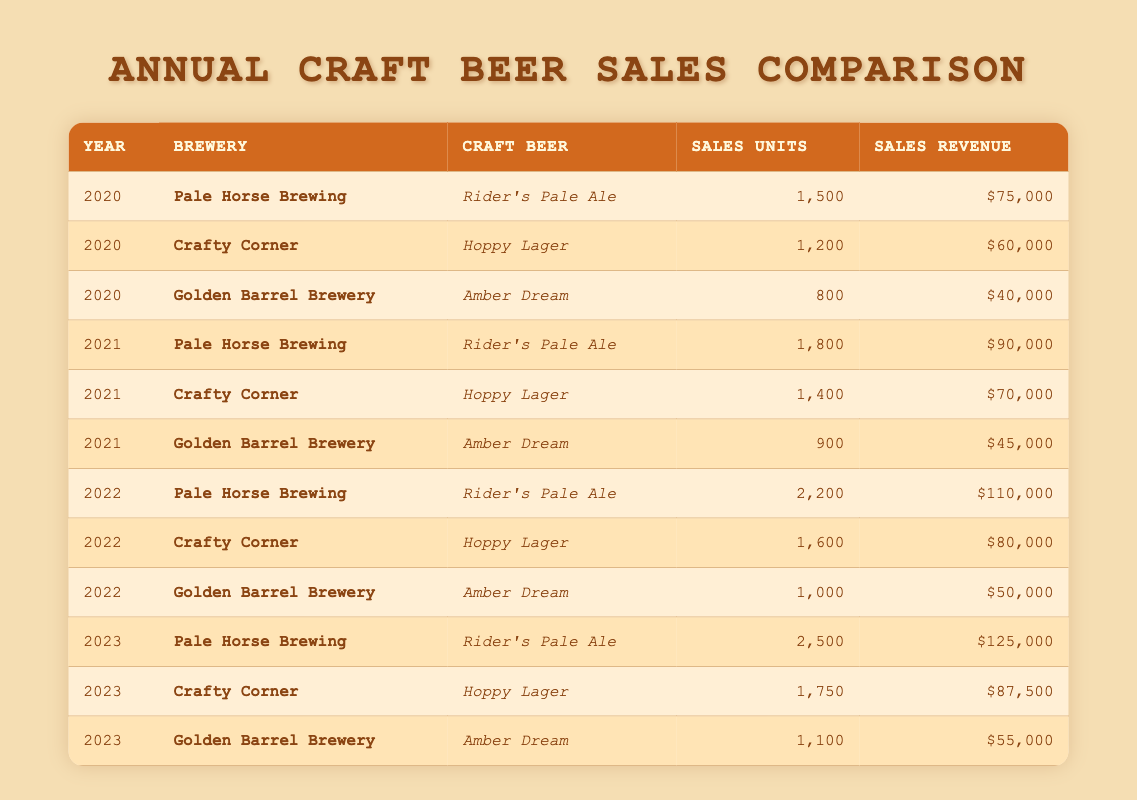What were the sales units for Rider's Pale Ale in 2021? In the table for the year 2021 and the brewery Pale Horse Brewing, the sales units for Rider's Pale Ale are listed as 1800.
Answer: 1800 What is the sales revenue for Hoppy Lager in 2023? Looking at the row for the year 2023 for Crafty Corner, the sales revenue for Hoppy Lager is indicated as 87500.
Answer: 87500 Which craft beer had the highest sales revenue in 2022? In 2022, comparing the sales revenue across all craft beers, Rider's Pale Ale from Pale Horse Brewing generated 110000, which is higher than Hoppy Lager and Amber Dream.
Answer: Rider's Pale Ale What was the increase in sales units for Amber Dream from 2021 to 2022? The sales units for Amber Dream in 2021 were 900, while in 2022, they were 1000. The increase can be calculated as 1000 - 900 = 100.
Answer: 100 Did Crafty Corner have higher sales revenue in 2020 than in 2021? Looking at the sales revenue for Crafty Corner, it was 60000 in 2020 and increased to 70000 in 2021. Therefore, the statement is false.
Answer: No What is the average sales units for Golden Barrel Brewery across all years? Summing up the sales units for Golden Barrel Brewery: 800 (2020) + 900 (2021) + 1000 (2022) + 1100 (2023) = 3800. There are 4 data points, so the average is 3800 / 4 = 950.
Answer: 950 Which brewery consistently increased its sales units each year? Analyzing the data, Pale Horse Brewing's sales units increased from 1500 in 2020 to 2500 in 2023, indicating a consistent rise every year.
Answer: Pale Horse Brewing What was the total sales revenue for Crafty Corner from 2020 to 2022? Calculating the total revenue: 60000 (2020) + 70000 (2021) + 80000 (2022) = 210000.
Answer: 210000 How much did the sales revenue for Amber Dream change from 2020 to 2023? Analyzing the revenue: Amber Dream's revenue was 40000 in 2020 and grew to 55000 in 2023. The change is determined by 55000 - 40000 = 15000.
Answer: 15000 